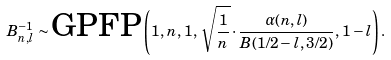<formula> <loc_0><loc_0><loc_500><loc_500>B _ { n , l } ^ { - 1 } \sim \text {GPFP} \left ( 1 , \, n , \, 1 , \, \sqrt { \frac { 1 } { n } } \cdot \frac { \alpha ( n , l ) } { B ( 1 / 2 - l , 3 / 2 ) } , \, 1 - l \right ) .</formula> 